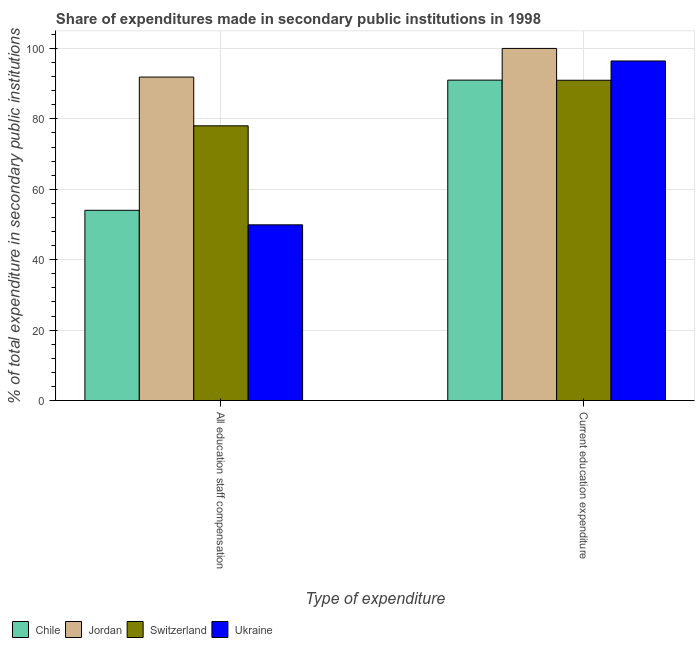Are the number of bars per tick equal to the number of legend labels?
Ensure brevity in your answer.  Yes. Are the number of bars on each tick of the X-axis equal?
Keep it short and to the point. Yes. What is the label of the 2nd group of bars from the left?
Your answer should be very brief. Current education expenditure. What is the expenditure in staff compensation in Jordan?
Your response must be concise. 91.87. Across all countries, what is the maximum expenditure in staff compensation?
Your answer should be very brief. 91.87. Across all countries, what is the minimum expenditure in staff compensation?
Your response must be concise. 49.91. In which country was the expenditure in staff compensation maximum?
Your answer should be very brief. Jordan. In which country was the expenditure in education minimum?
Your answer should be compact. Switzerland. What is the total expenditure in staff compensation in the graph?
Your answer should be compact. 273.83. What is the difference between the expenditure in education in Ukraine and that in Jordan?
Provide a short and direct response. -3.56. What is the difference between the expenditure in education in Switzerland and the expenditure in staff compensation in Ukraine?
Make the answer very short. 41.06. What is the average expenditure in education per country?
Offer a terse response. 94.6. What is the difference between the expenditure in staff compensation and expenditure in education in Jordan?
Keep it short and to the point. -8.13. In how many countries, is the expenditure in education greater than 88 %?
Give a very brief answer. 4. What is the ratio of the expenditure in staff compensation in Switzerland to that in Jordan?
Your answer should be very brief. 0.85. In how many countries, is the expenditure in staff compensation greater than the average expenditure in staff compensation taken over all countries?
Give a very brief answer. 2. What does the 3rd bar from the left in Current education expenditure represents?
Your response must be concise. Switzerland. What does the 2nd bar from the right in All education staff compensation represents?
Your answer should be very brief. Switzerland. How many bars are there?
Make the answer very short. 8. How many countries are there in the graph?
Offer a terse response. 4. What is the difference between two consecutive major ticks on the Y-axis?
Give a very brief answer. 20. Are the values on the major ticks of Y-axis written in scientific E-notation?
Your answer should be very brief. No. Does the graph contain any zero values?
Keep it short and to the point. No. How many legend labels are there?
Ensure brevity in your answer.  4. How are the legend labels stacked?
Ensure brevity in your answer.  Horizontal. What is the title of the graph?
Your answer should be very brief. Share of expenditures made in secondary public institutions in 1998. What is the label or title of the X-axis?
Your response must be concise. Type of expenditure. What is the label or title of the Y-axis?
Ensure brevity in your answer.  % of total expenditure in secondary public institutions. What is the % of total expenditure in secondary public institutions in Chile in All education staff compensation?
Ensure brevity in your answer.  54.03. What is the % of total expenditure in secondary public institutions in Jordan in All education staff compensation?
Your answer should be compact. 91.87. What is the % of total expenditure in secondary public institutions in Switzerland in All education staff compensation?
Your answer should be compact. 78.02. What is the % of total expenditure in secondary public institutions in Ukraine in All education staff compensation?
Your response must be concise. 49.91. What is the % of total expenditure in secondary public institutions of Chile in Current education expenditure?
Give a very brief answer. 91. What is the % of total expenditure in secondary public institutions of Switzerland in Current education expenditure?
Keep it short and to the point. 90.96. What is the % of total expenditure in secondary public institutions of Ukraine in Current education expenditure?
Give a very brief answer. 96.44. Across all Type of expenditure, what is the maximum % of total expenditure in secondary public institutions in Chile?
Make the answer very short. 91. Across all Type of expenditure, what is the maximum % of total expenditure in secondary public institutions of Jordan?
Offer a terse response. 100. Across all Type of expenditure, what is the maximum % of total expenditure in secondary public institutions in Switzerland?
Ensure brevity in your answer.  90.96. Across all Type of expenditure, what is the maximum % of total expenditure in secondary public institutions of Ukraine?
Provide a succinct answer. 96.44. Across all Type of expenditure, what is the minimum % of total expenditure in secondary public institutions in Chile?
Ensure brevity in your answer.  54.03. Across all Type of expenditure, what is the minimum % of total expenditure in secondary public institutions of Jordan?
Your answer should be compact. 91.87. Across all Type of expenditure, what is the minimum % of total expenditure in secondary public institutions of Switzerland?
Offer a very short reply. 78.02. Across all Type of expenditure, what is the minimum % of total expenditure in secondary public institutions of Ukraine?
Ensure brevity in your answer.  49.91. What is the total % of total expenditure in secondary public institutions of Chile in the graph?
Ensure brevity in your answer.  145.03. What is the total % of total expenditure in secondary public institutions in Jordan in the graph?
Your answer should be very brief. 191.87. What is the total % of total expenditure in secondary public institutions in Switzerland in the graph?
Give a very brief answer. 168.99. What is the total % of total expenditure in secondary public institutions in Ukraine in the graph?
Provide a short and direct response. 146.35. What is the difference between the % of total expenditure in secondary public institutions in Chile in All education staff compensation and that in Current education expenditure?
Make the answer very short. -36.97. What is the difference between the % of total expenditure in secondary public institutions in Jordan in All education staff compensation and that in Current education expenditure?
Provide a short and direct response. -8.13. What is the difference between the % of total expenditure in secondary public institutions in Switzerland in All education staff compensation and that in Current education expenditure?
Your response must be concise. -12.94. What is the difference between the % of total expenditure in secondary public institutions of Ukraine in All education staff compensation and that in Current education expenditure?
Offer a terse response. -46.53. What is the difference between the % of total expenditure in secondary public institutions in Chile in All education staff compensation and the % of total expenditure in secondary public institutions in Jordan in Current education expenditure?
Ensure brevity in your answer.  -45.97. What is the difference between the % of total expenditure in secondary public institutions in Chile in All education staff compensation and the % of total expenditure in secondary public institutions in Switzerland in Current education expenditure?
Offer a terse response. -36.93. What is the difference between the % of total expenditure in secondary public institutions in Chile in All education staff compensation and the % of total expenditure in secondary public institutions in Ukraine in Current education expenditure?
Your response must be concise. -42.41. What is the difference between the % of total expenditure in secondary public institutions of Jordan in All education staff compensation and the % of total expenditure in secondary public institutions of Switzerland in Current education expenditure?
Give a very brief answer. 0.9. What is the difference between the % of total expenditure in secondary public institutions of Jordan in All education staff compensation and the % of total expenditure in secondary public institutions of Ukraine in Current education expenditure?
Your answer should be very brief. -4.57. What is the difference between the % of total expenditure in secondary public institutions in Switzerland in All education staff compensation and the % of total expenditure in secondary public institutions in Ukraine in Current education expenditure?
Your answer should be compact. -18.41. What is the average % of total expenditure in secondary public institutions of Chile per Type of expenditure?
Your answer should be compact. 72.51. What is the average % of total expenditure in secondary public institutions in Jordan per Type of expenditure?
Your answer should be very brief. 95.93. What is the average % of total expenditure in secondary public institutions in Switzerland per Type of expenditure?
Ensure brevity in your answer.  84.49. What is the average % of total expenditure in secondary public institutions in Ukraine per Type of expenditure?
Provide a succinct answer. 73.17. What is the difference between the % of total expenditure in secondary public institutions in Chile and % of total expenditure in secondary public institutions in Jordan in All education staff compensation?
Keep it short and to the point. -37.84. What is the difference between the % of total expenditure in secondary public institutions of Chile and % of total expenditure in secondary public institutions of Switzerland in All education staff compensation?
Provide a short and direct response. -23.99. What is the difference between the % of total expenditure in secondary public institutions in Chile and % of total expenditure in secondary public institutions in Ukraine in All education staff compensation?
Your answer should be compact. 4.12. What is the difference between the % of total expenditure in secondary public institutions of Jordan and % of total expenditure in secondary public institutions of Switzerland in All education staff compensation?
Keep it short and to the point. 13.85. What is the difference between the % of total expenditure in secondary public institutions of Jordan and % of total expenditure in secondary public institutions of Ukraine in All education staff compensation?
Give a very brief answer. 41.96. What is the difference between the % of total expenditure in secondary public institutions of Switzerland and % of total expenditure in secondary public institutions of Ukraine in All education staff compensation?
Your response must be concise. 28.12. What is the difference between the % of total expenditure in secondary public institutions in Chile and % of total expenditure in secondary public institutions in Jordan in Current education expenditure?
Your answer should be compact. -9. What is the difference between the % of total expenditure in secondary public institutions of Chile and % of total expenditure in secondary public institutions of Switzerland in Current education expenditure?
Provide a succinct answer. 0.03. What is the difference between the % of total expenditure in secondary public institutions in Chile and % of total expenditure in secondary public institutions in Ukraine in Current education expenditure?
Your response must be concise. -5.44. What is the difference between the % of total expenditure in secondary public institutions in Jordan and % of total expenditure in secondary public institutions in Switzerland in Current education expenditure?
Your response must be concise. 9.04. What is the difference between the % of total expenditure in secondary public institutions in Jordan and % of total expenditure in secondary public institutions in Ukraine in Current education expenditure?
Keep it short and to the point. 3.56. What is the difference between the % of total expenditure in secondary public institutions in Switzerland and % of total expenditure in secondary public institutions in Ukraine in Current education expenditure?
Your answer should be very brief. -5.47. What is the ratio of the % of total expenditure in secondary public institutions in Chile in All education staff compensation to that in Current education expenditure?
Your answer should be compact. 0.59. What is the ratio of the % of total expenditure in secondary public institutions of Jordan in All education staff compensation to that in Current education expenditure?
Offer a terse response. 0.92. What is the ratio of the % of total expenditure in secondary public institutions of Switzerland in All education staff compensation to that in Current education expenditure?
Keep it short and to the point. 0.86. What is the ratio of the % of total expenditure in secondary public institutions of Ukraine in All education staff compensation to that in Current education expenditure?
Provide a succinct answer. 0.52. What is the difference between the highest and the second highest % of total expenditure in secondary public institutions of Chile?
Provide a short and direct response. 36.97. What is the difference between the highest and the second highest % of total expenditure in secondary public institutions in Jordan?
Your answer should be compact. 8.13. What is the difference between the highest and the second highest % of total expenditure in secondary public institutions of Switzerland?
Keep it short and to the point. 12.94. What is the difference between the highest and the second highest % of total expenditure in secondary public institutions of Ukraine?
Make the answer very short. 46.53. What is the difference between the highest and the lowest % of total expenditure in secondary public institutions in Chile?
Offer a terse response. 36.97. What is the difference between the highest and the lowest % of total expenditure in secondary public institutions in Jordan?
Offer a very short reply. 8.13. What is the difference between the highest and the lowest % of total expenditure in secondary public institutions of Switzerland?
Your response must be concise. 12.94. What is the difference between the highest and the lowest % of total expenditure in secondary public institutions of Ukraine?
Ensure brevity in your answer.  46.53. 